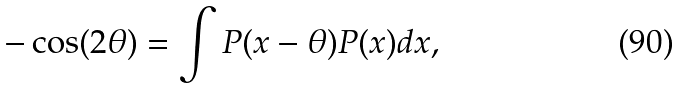Convert formula to latex. <formula><loc_0><loc_0><loc_500><loc_500>- \cos ( 2 \theta ) = \int P ( x - \theta ) P ( x ) d x ,</formula> 